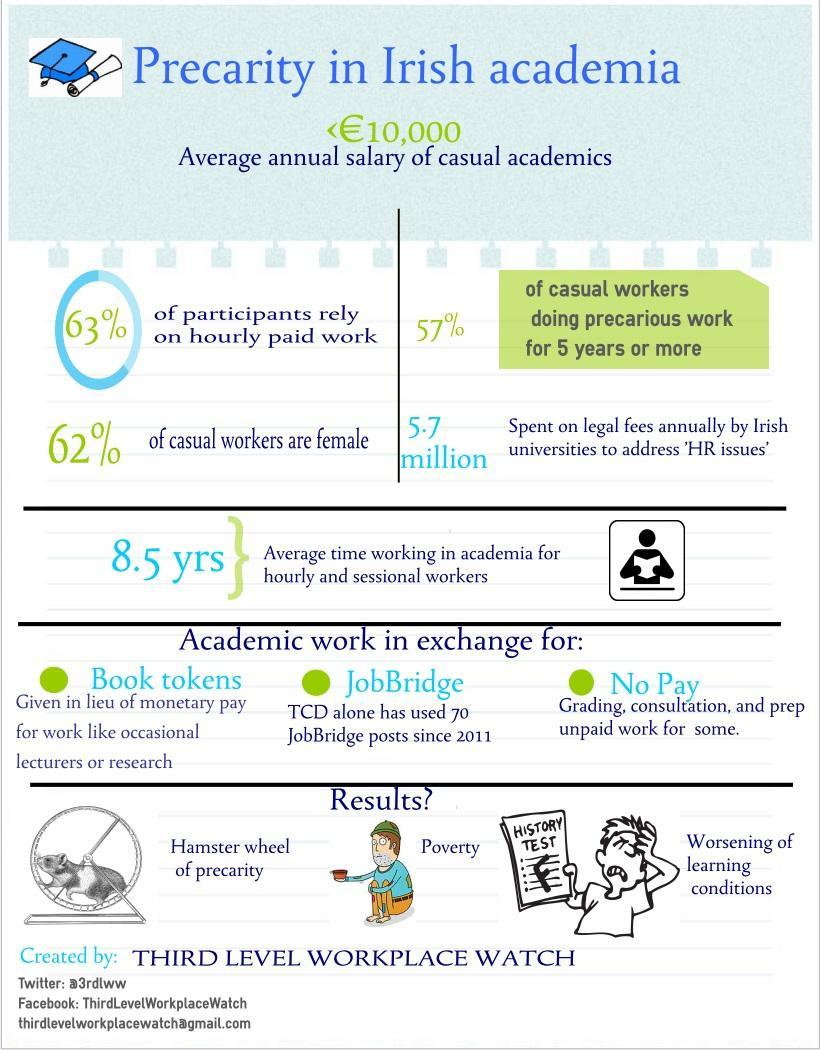What percentage of casual workers are males in Irish academia?
Answer the question with a short phrase. 38% What percentage of participants do not rely on hourly paid work in Irish academia? 37% 